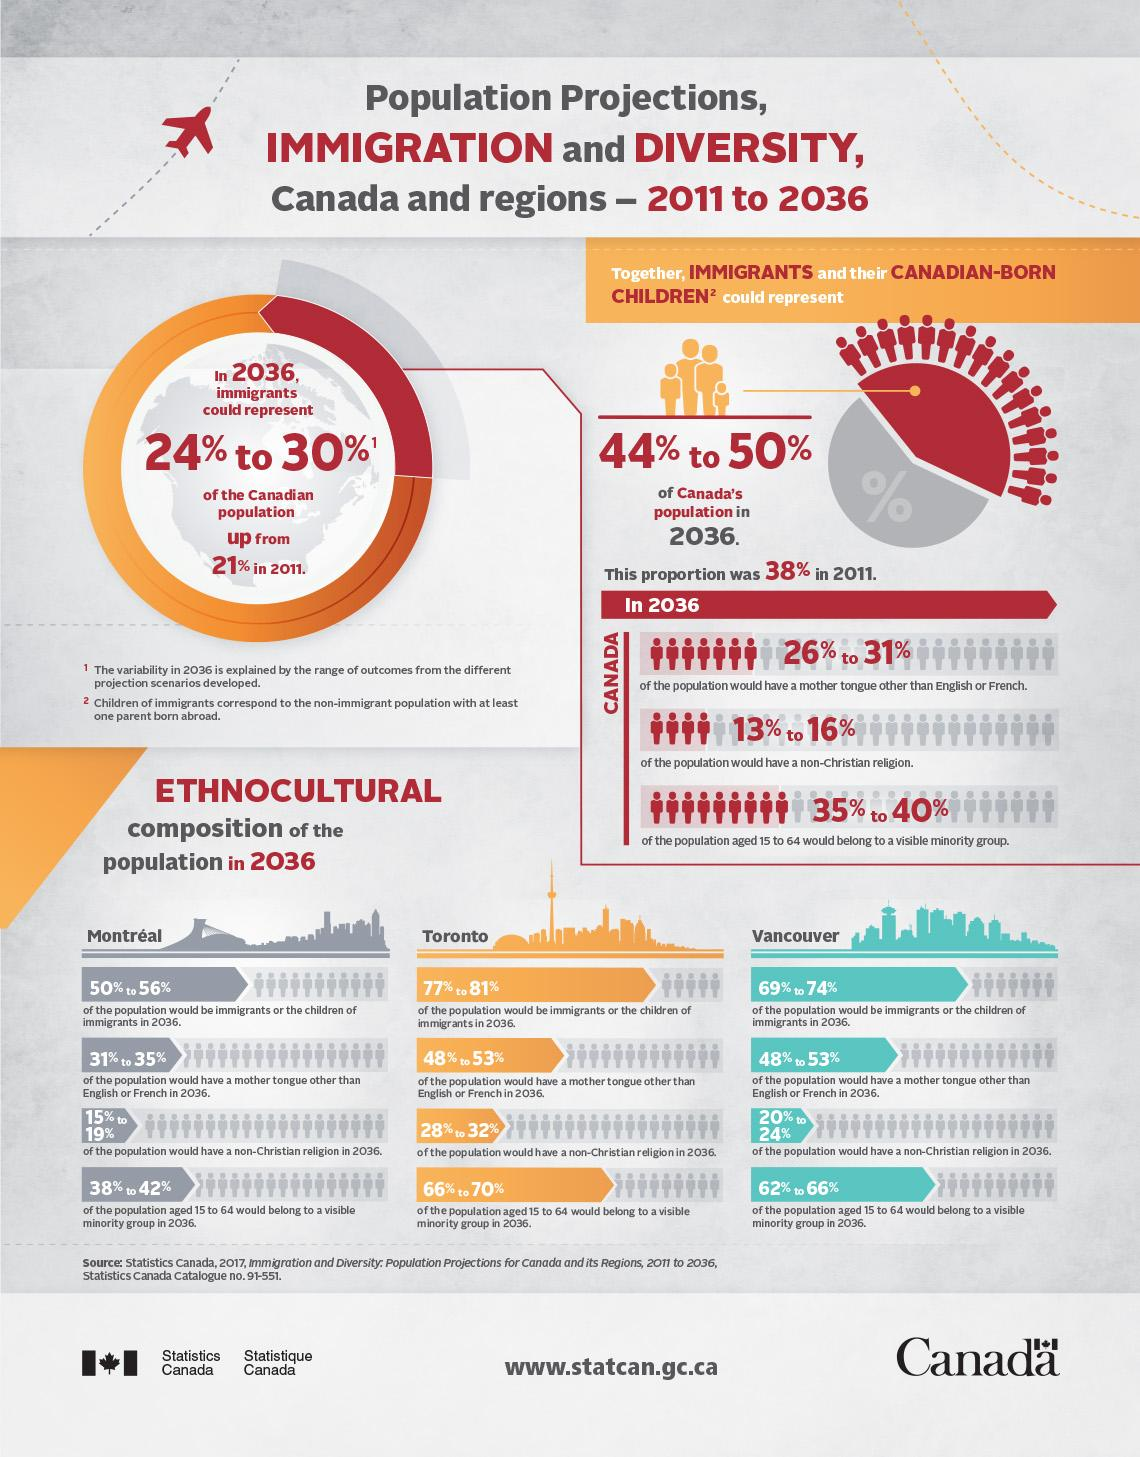Outline some significant characteristics in this image. In 2036, it is estimated that between 48% and 53% of Toronto's population will have a mother tongue other than English or French. According to projections, by 2036, between 15% and 19% of Montreal's population will have a non-Christian religion. In 2011, 38% of Canada's population were immigrants or the children of immigrants. In 2036, it is projected that between 66% and 70% of Toronto's population aged 15-64 years will belong to a visible minority group. In 2011, a significant portion of Vancouver's population, ranging from 69% to 74%, consisted of immigrants or the children of immigrants. 